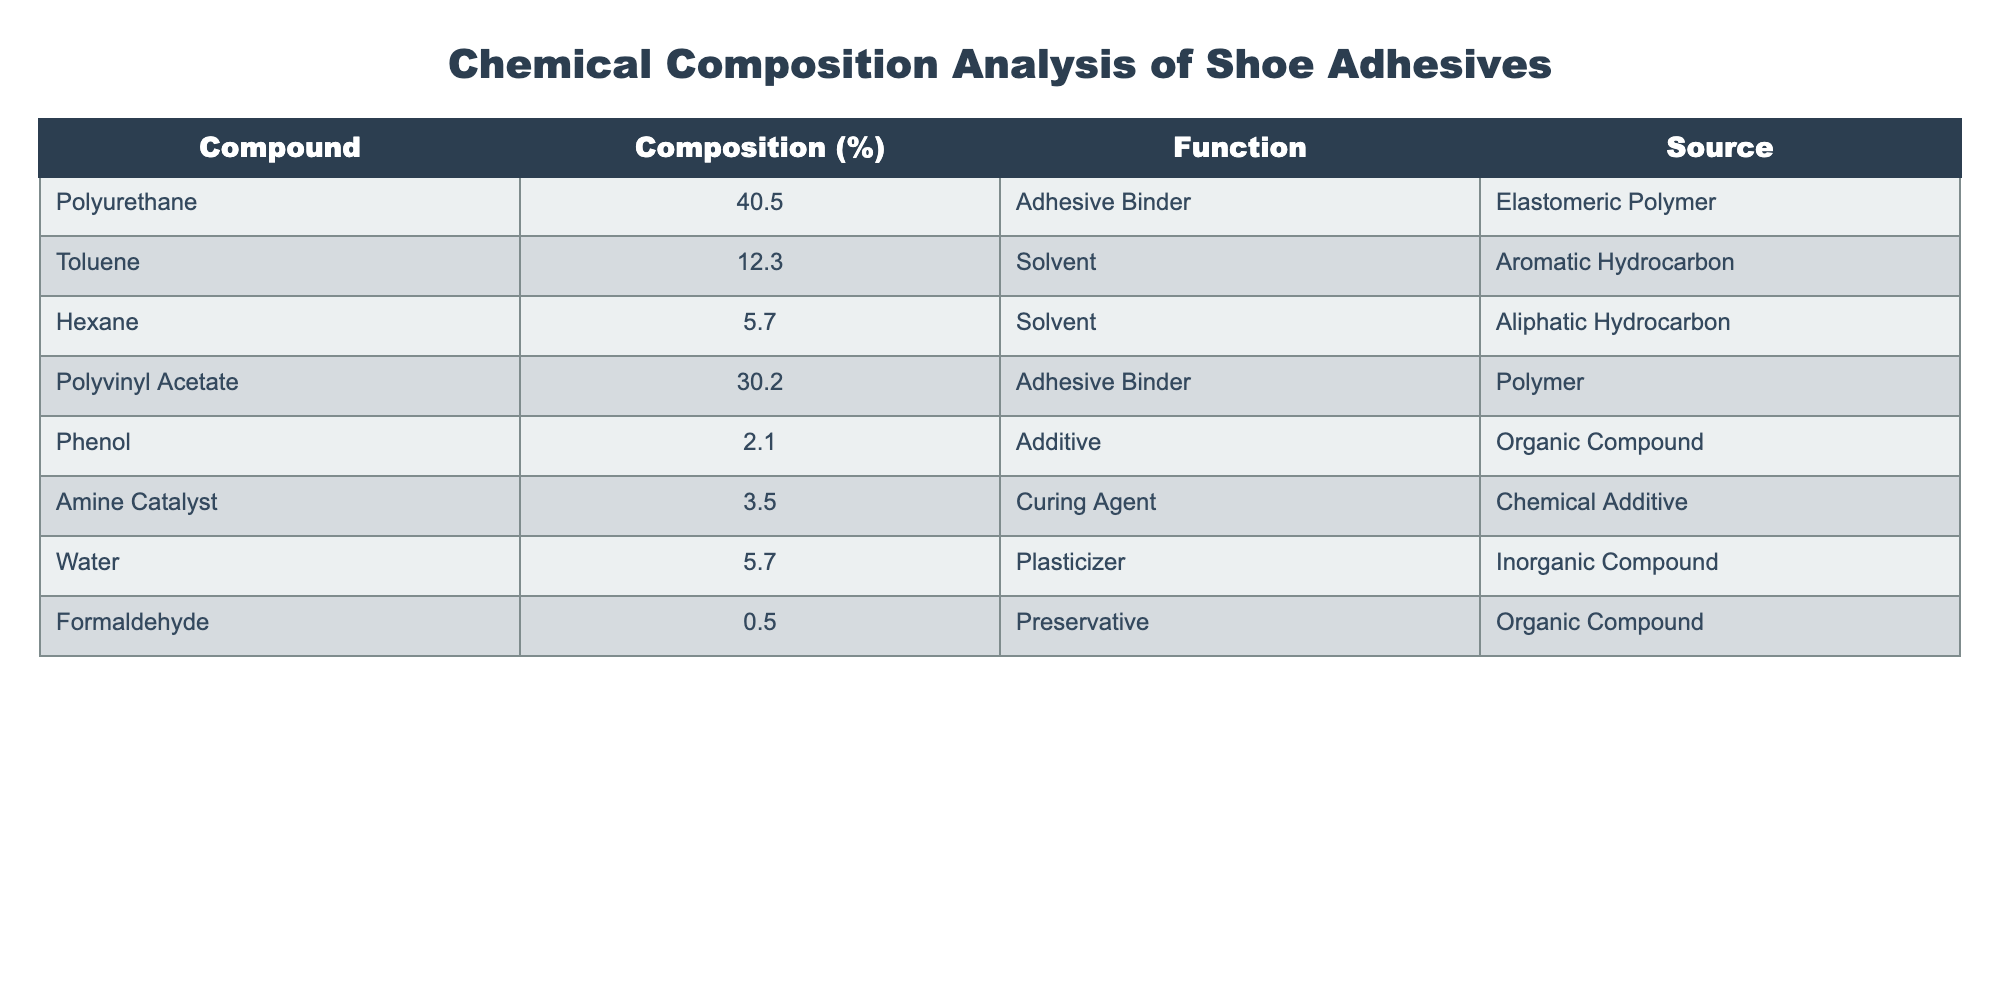What is the function of Toluene in the adhesive composition? The table lists Toluene under the 'Function' column as a 'Solvent.'
Answer: Solvent What percentage of the adhesive composition is made up of Polyvinyl Acetate? Polyvinyl Acetate's percentage is directly available in the table, listed as 30.2%.
Answer: 30.2% Which two compounds combined contribute the highest percentage to the adhesive composition? The highest percentages are from Polyurethane (40.5%) and Polyvinyl Acetate (30.2%). When combined, they total 70.7% (40.5 + 30.2).
Answer: Polyurethane and Polyvinyl Acetate Is Formaldehyde present in the adhesive composition? The table indicates that Formaldehyde is listed with a composition of 0.5%, confirming its presence.
Answer: Yes What is the total percentage of solvents in the adhesive composition? The solvents listed are Toluene (12.3%) and Hexane (5.7%). Adding these gives a total of 18% (12.3 + 5.7).
Answer: 18% What is the function of Amine Catalyst in the adhesive composition? According to the table, the function of Amine Catalyst is labeled as a 'Curing Agent.'
Answer: Curing Agent What is the average percentage of the additives listed (Phenol and Water)? The table shows Phenol at 2.1% and Water at 5.7%. To find the average, sum these percentages to get 7.8% and then divide by 2. The calculation is 7.8/2 = 3.9%.
Answer: 3.9% How much lower is the percentage of Amine Catalyst compared to Polyvinyl Acetate? Amine Catalyst is 3.5% and Polyvinyl Acetate is 30.2%. The difference is calculated as 30.2 - 3.5 = 26.7%.
Answer: 26.7% What is the percentage of additives (Phenol and Formaldehyde) compared to the total composition? The total percentage of additives is Phenol (2.1%) plus Formaldehyde (0.5%), which totals 2.6%. This is compared to the total composition of 100%, which leads to a percentage of additives/total composition = 2.6%.
Answer: 2.6% 